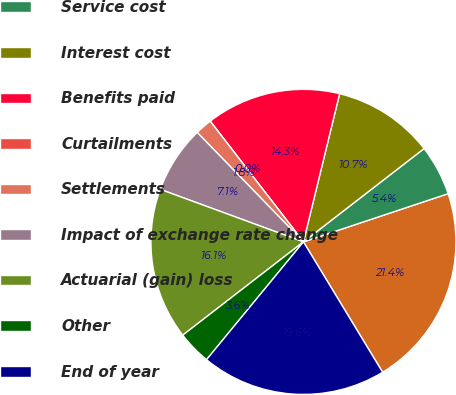Convert chart to OTSL. <chart><loc_0><loc_0><loc_500><loc_500><pie_chart><fcel>Beginning of year<fcel>Service cost<fcel>Interest cost<fcel>Benefits paid<fcel>Curtailments<fcel>Settlements<fcel>Impact of exchange rate change<fcel>Actuarial (gain) loss<fcel>Other<fcel>End of year<nl><fcel>21.43%<fcel>5.36%<fcel>10.71%<fcel>14.28%<fcel>0.0%<fcel>1.79%<fcel>7.14%<fcel>16.07%<fcel>3.57%<fcel>19.64%<nl></chart> 